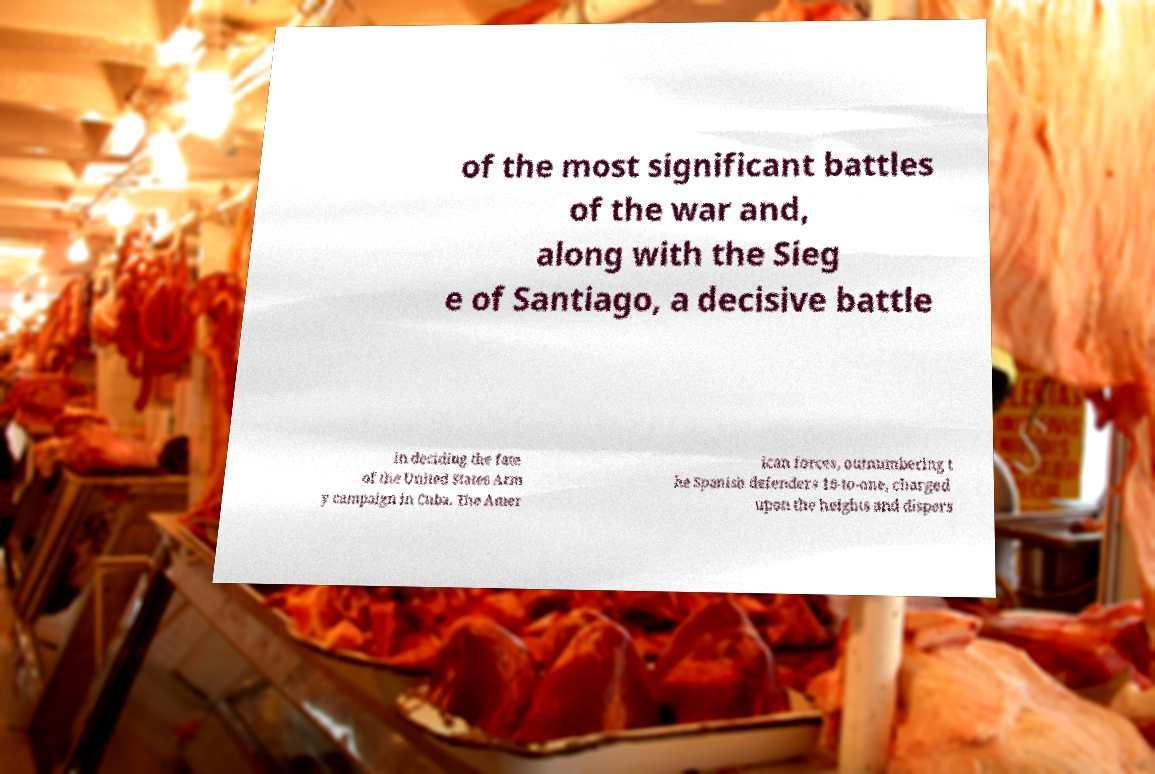For documentation purposes, I need the text within this image transcribed. Could you provide that? of the most significant battles of the war and, along with the Sieg e of Santiago, a decisive battle in deciding the fate of the United States Arm y campaign in Cuba. The Amer ican forces, outnumbering t he Spanish defenders 16-to-one, charged upon the heights and dispers 